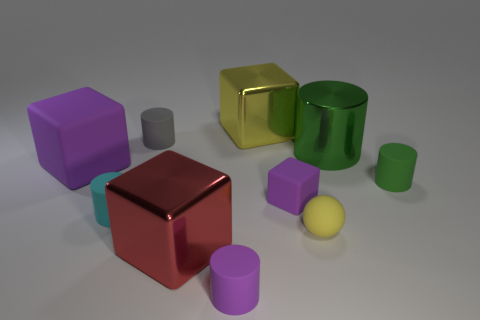Is there any other thing that has the same shape as the yellow rubber object?
Your answer should be compact. No. Is the color of the tiny cube the same as the big matte thing?
Your answer should be compact. Yes. Do the tiny yellow thing and the purple thing that is to the left of the tiny purple rubber cylinder have the same material?
Ensure brevity in your answer.  Yes. What size is the yellow object that is made of the same material as the big cylinder?
Offer a very short reply. Large. Is the number of purple objects behind the small yellow rubber object greater than the number of cyan rubber things in front of the red metallic cube?
Ensure brevity in your answer.  Yes. Are there any big red metallic things of the same shape as the tiny gray rubber thing?
Give a very brief answer. No. Does the metallic block behind the green rubber cylinder have the same size as the red metallic cube?
Offer a very short reply. Yes. Are any large blue metal cylinders visible?
Offer a very short reply. No. How many objects are either small rubber cylinders in front of the small sphere or blue metal objects?
Your answer should be compact. 1. Is the color of the large matte block the same as the tiny object that is in front of the tiny ball?
Offer a terse response. Yes. 